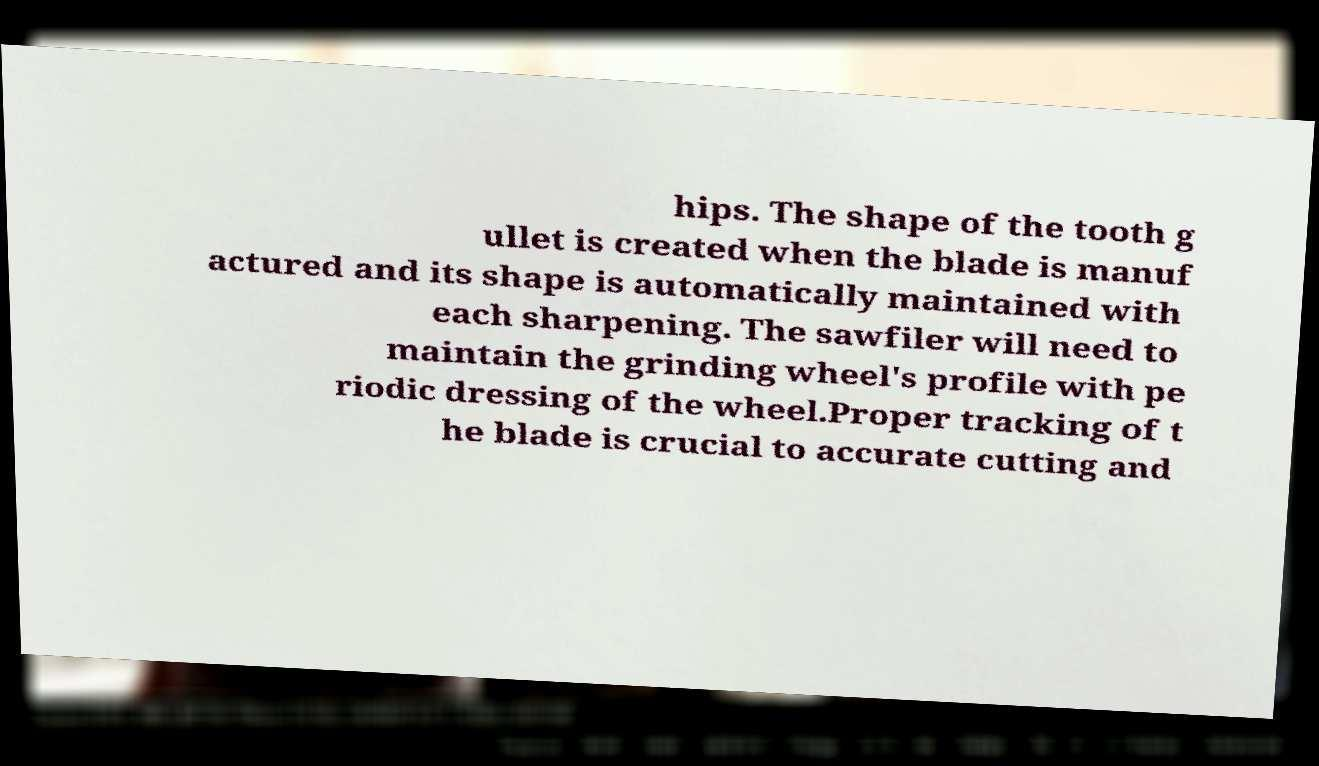Please read and relay the text visible in this image. What does it say? hips. The shape of the tooth g ullet is created when the blade is manuf actured and its shape is automatically maintained with each sharpening. The sawfiler will need to maintain the grinding wheel's profile with pe riodic dressing of the wheel.Proper tracking of t he blade is crucial to accurate cutting and 